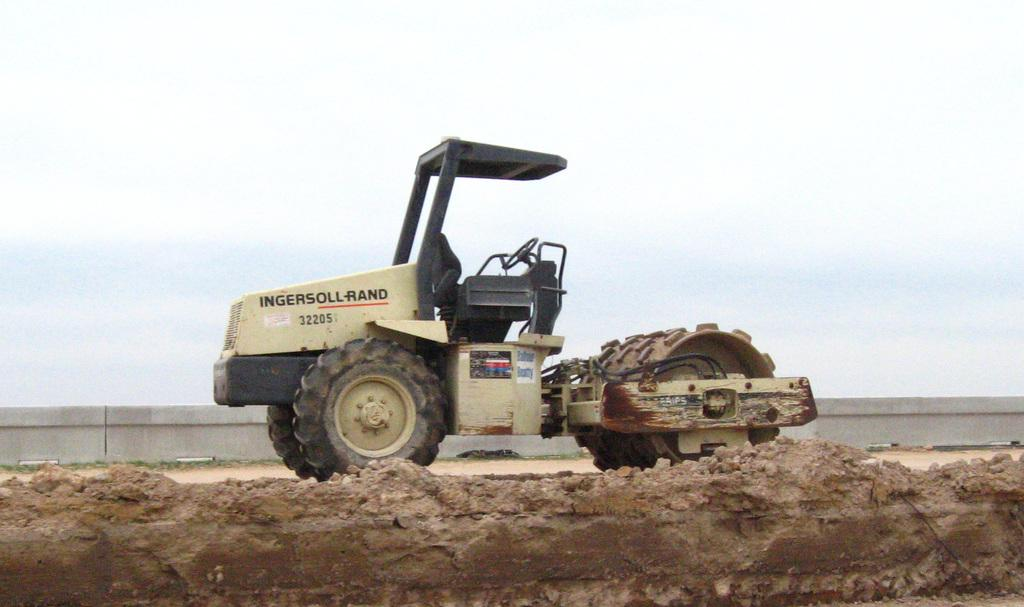What type of vehicle can be seen in the image? There is a vehicle that looks like a bulldozer in the image. What other vehicle is present in the image? There is a tractor in the image. What is the ground made of in the image? The bottom of the image contains soil or mud. What can be seen in the background of the image? There is a wall in the background of the image. What is visible at the top of the image? The sky is visible at the top of the image. How many teeth can be seen on the bulldozer in the image? There are no teeth visible on the bulldozer in the image, as it is a vehicle and not a living organism. What type of harbor is visible in the image? There is no harbor present in the image; it features a bulldozer, tractor, soil or mud, a wall, and the sky. 